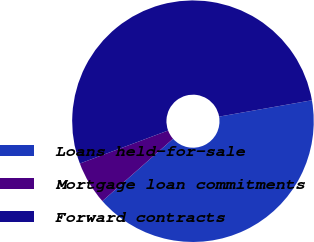Convert chart. <chart><loc_0><loc_0><loc_500><loc_500><pie_chart><fcel>Loans held-for-sale<fcel>Mortgage loan commitments<fcel>Forward contracts<nl><fcel>41.28%<fcel>5.8%<fcel>52.93%<nl></chart> 